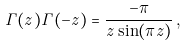<formula> <loc_0><loc_0><loc_500><loc_500>\Gamma ( z ) \Gamma ( - z ) = \frac { - \pi } { z \sin ( \pi z ) } \, ,</formula> 